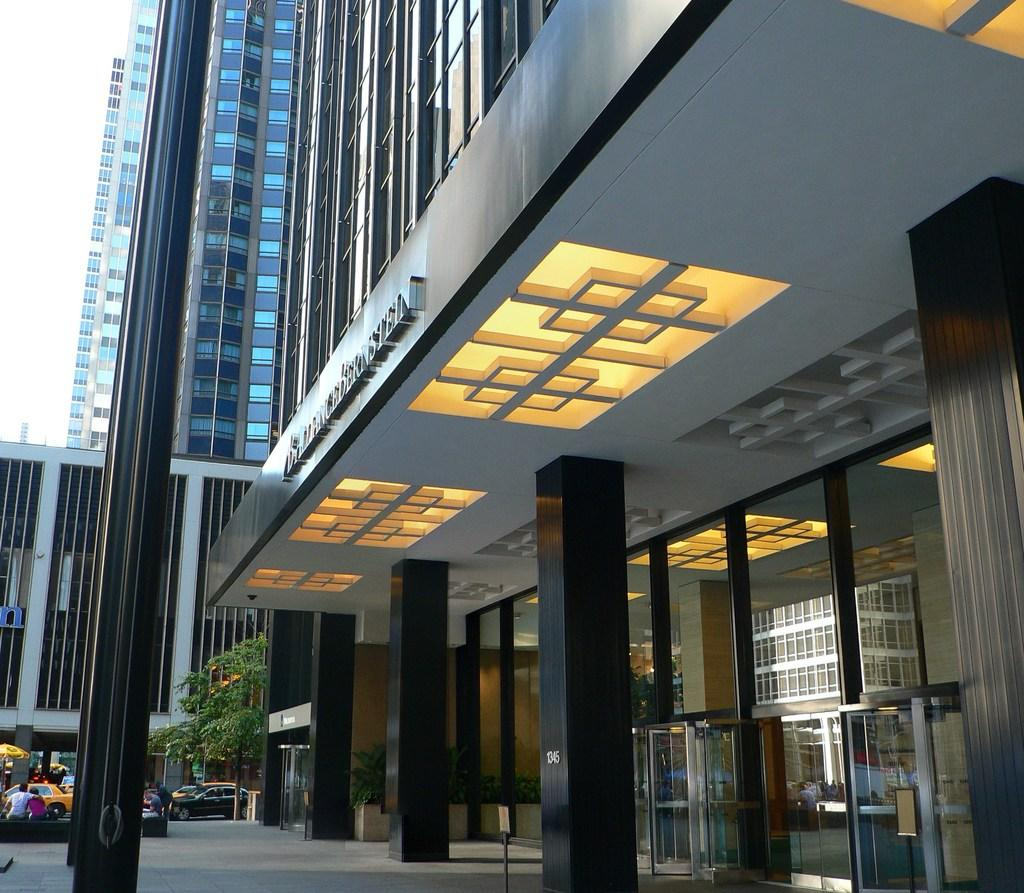What structure is located in the right corner of the image? There is a building in the right corner of the image. What can be seen in the left corner of the image? There are people and vehicles in the left corner of the image. What type of chalk is being used by the people in the image? There is no chalk present in the image. What flavor of mint can be smelled coming from the vehicles in the image? There is no mention of mint or any scent in the image. 